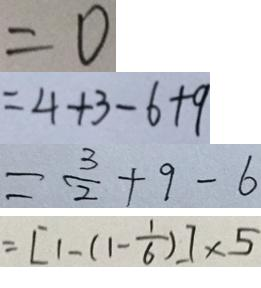<formula> <loc_0><loc_0><loc_500><loc_500>= 0 
 = 4 + 3 - 6 + 9 
 = \frac { 3 } { 2 } + 9 - 6 
 = [ 1 - ( 1 - \frac { 1 } { 6 } ) ] \times 5</formula> 